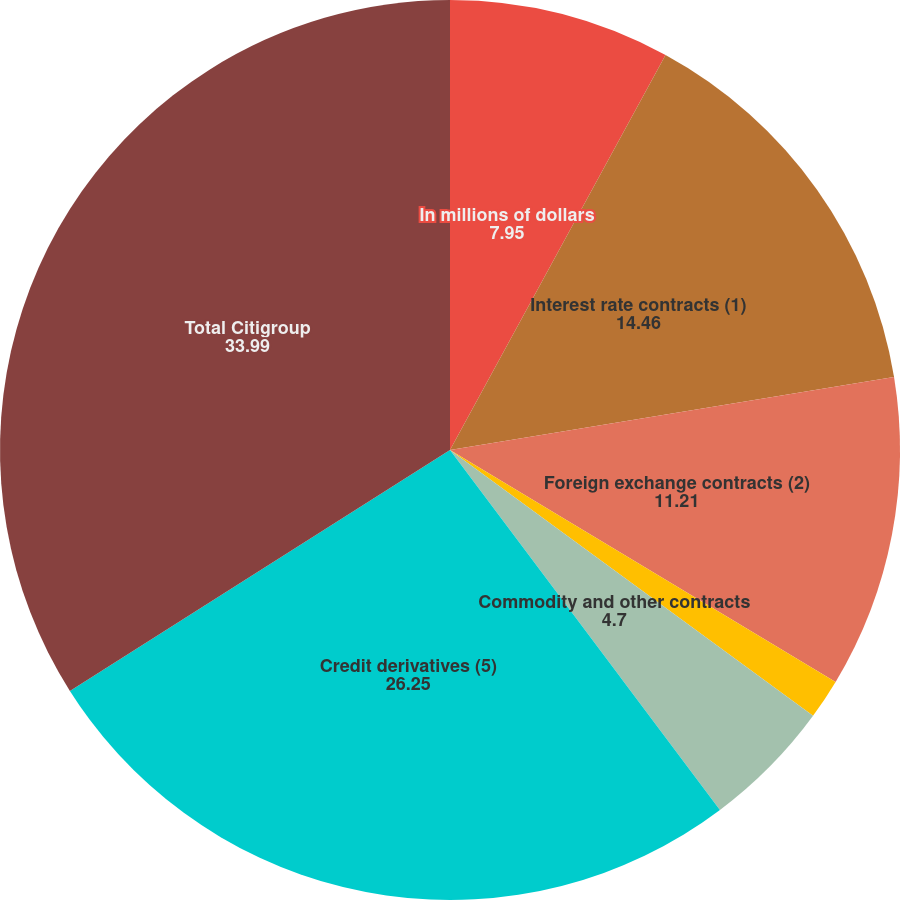Convert chart to OTSL. <chart><loc_0><loc_0><loc_500><loc_500><pie_chart><fcel>In millions of dollars<fcel>Interest rate contracts (1)<fcel>Foreign exchange contracts (2)<fcel>Equity contracts (3)<fcel>Commodity and other contracts<fcel>Credit derivatives (5)<fcel>Total Citigroup<nl><fcel>7.95%<fcel>14.46%<fcel>11.21%<fcel>1.44%<fcel>4.7%<fcel>26.25%<fcel>33.99%<nl></chart> 